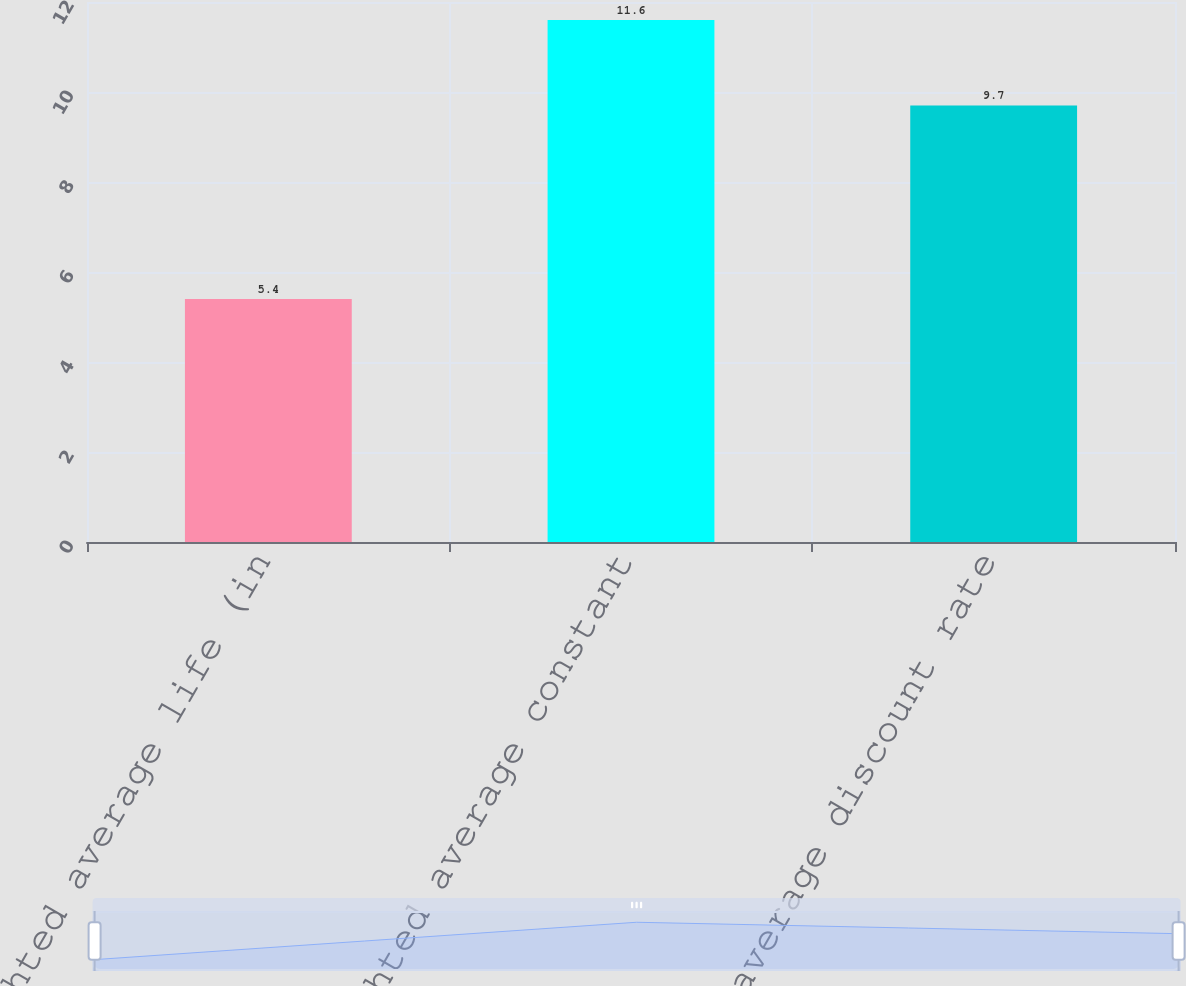Convert chart. <chart><loc_0><loc_0><loc_500><loc_500><bar_chart><fcel>Weighted average life (in<fcel>Weighted average constant<fcel>Weighted average discount rate<nl><fcel>5.4<fcel>11.6<fcel>9.7<nl></chart> 